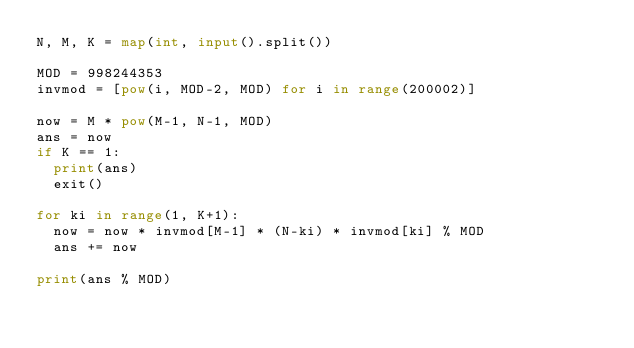Convert code to text. <code><loc_0><loc_0><loc_500><loc_500><_Python_>N, M, K = map(int, input().split())

MOD = 998244353
invmod = [pow(i, MOD-2, MOD) for i in range(200002)]

now = M * pow(M-1, N-1, MOD)
ans = now
if K == 1:
  print(ans)
  exit()

for ki in range(1, K+1):
  now = now * invmod[M-1] * (N-ki) * invmod[ki] % MOD
  ans += now
  
print(ans % MOD)
</code> 